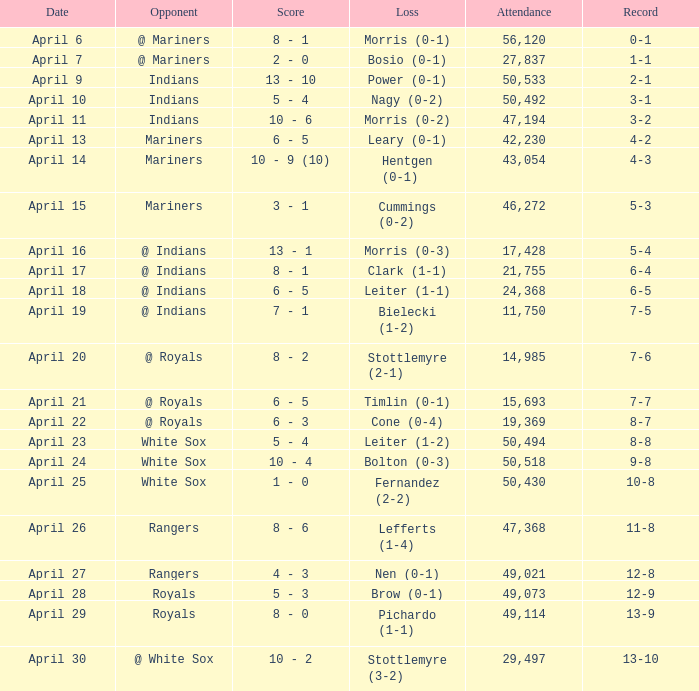What scored is recorded on April 24? 10 - 4. 